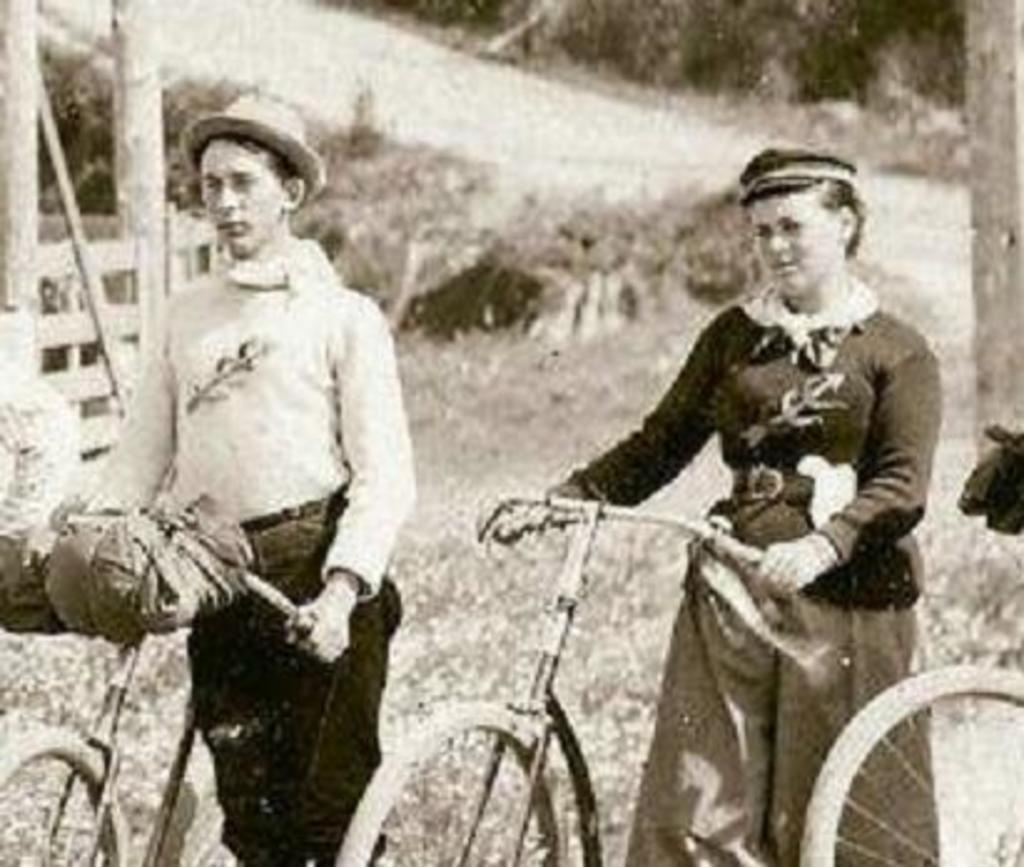How many people are in the image? There are two persons in the image. What are the two persons doing in the image? The two persons are holding a bicycle. What can be seen in the background of the image? There is soil, plants, and trees visible in the background of the image. What type of produce is being harvested by the men in the image? There are no men or produce present in the image; it features two persons holding a bicycle with a background of soil, plants, and trees. 